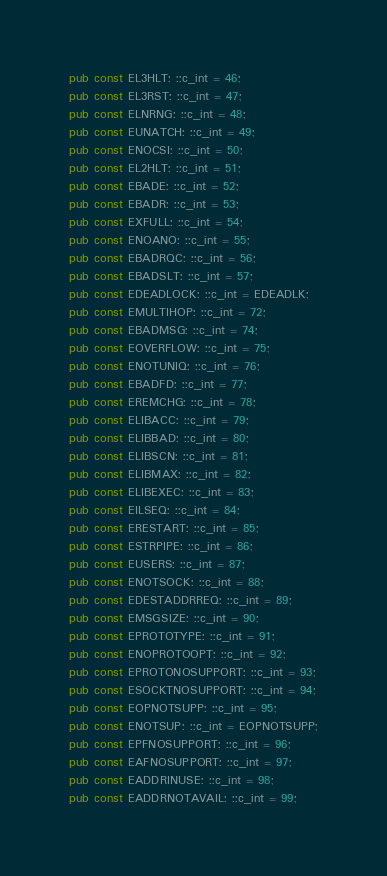Convert code to text. <code><loc_0><loc_0><loc_500><loc_500><_Rust_>pub const EL3HLT: ::c_int = 46;
pub const EL3RST: ::c_int = 47;
pub const ELNRNG: ::c_int = 48;
pub const EUNATCH: ::c_int = 49;
pub const ENOCSI: ::c_int = 50;
pub const EL2HLT: ::c_int = 51;
pub const EBADE: ::c_int = 52;
pub const EBADR: ::c_int = 53;
pub const EXFULL: ::c_int = 54;
pub const ENOANO: ::c_int = 55;
pub const EBADRQC: ::c_int = 56;
pub const EBADSLT: ::c_int = 57;
pub const EDEADLOCK: ::c_int = EDEADLK;
pub const EMULTIHOP: ::c_int = 72;
pub const EBADMSG: ::c_int = 74;
pub const EOVERFLOW: ::c_int = 75;
pub const ENOTUNIQ: ::c_int = 76;
pub const EBADFD: ::c_int = 77;
pub const EREMCHG: ::c_int = 78;
pub const ELIBACC: ::c_int = 79;
pub const ELIBBAD: ::c_int = 80;
pub const ELIBSCN: ::c_int = 81;
pub const ELIBMAX: ::c_int = 82;
pub const ELIBEXEC: ::c_int = 83;
pub const EILSEQ: ::c_int = 84;
pub const ERESTART: ::c_int = 85;
pub const ESTRPIPE: ::c_int = 86;
pub const EUSERS: ::c_int = 87;
pub const ENOTSOCK: ::c_int = 88;
pub const EDESTADDRREQ: ::c_int = 89;
pub const EMSGSIZE: ::c_int = 90;
pub const EPROTOTYPE: ::c_int = 91;
pub const ENOPROTOOPT: ::c_int = 92;
pub const EPROTONOSUPPORT: ::c_int = 93;
pub const ESOCKTNOSUPPORT: ::c_int = 94;
pub const EOPNOTSUPP: ::c_int = 95;
pub const ENOTSUP: ::c_int = EOPNOTSUPP;
pub const EPFNOSUPPORT: ::c_int = 96;
pub const EAFNOSUPPORT: ::c_int = 97;
pub const EADDRINUSE: ::c_int = 98;
pub const EADDRNOTAVAIL: ::c_int = 99;</code> 